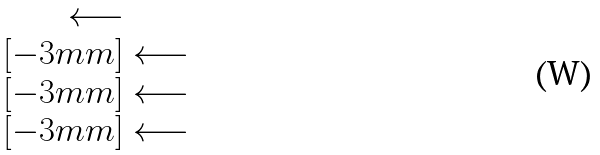<formula> <loc_0><loc_0><loc_500><loc_500>\begin{matrix} \longleftarrow \\ [ - 3 m m ] \longleftarrow \\ [ - 3 m m ] \longleftarrow \\ [ - 3 m m ] \longleftarrow \end{matrix}</formula> 